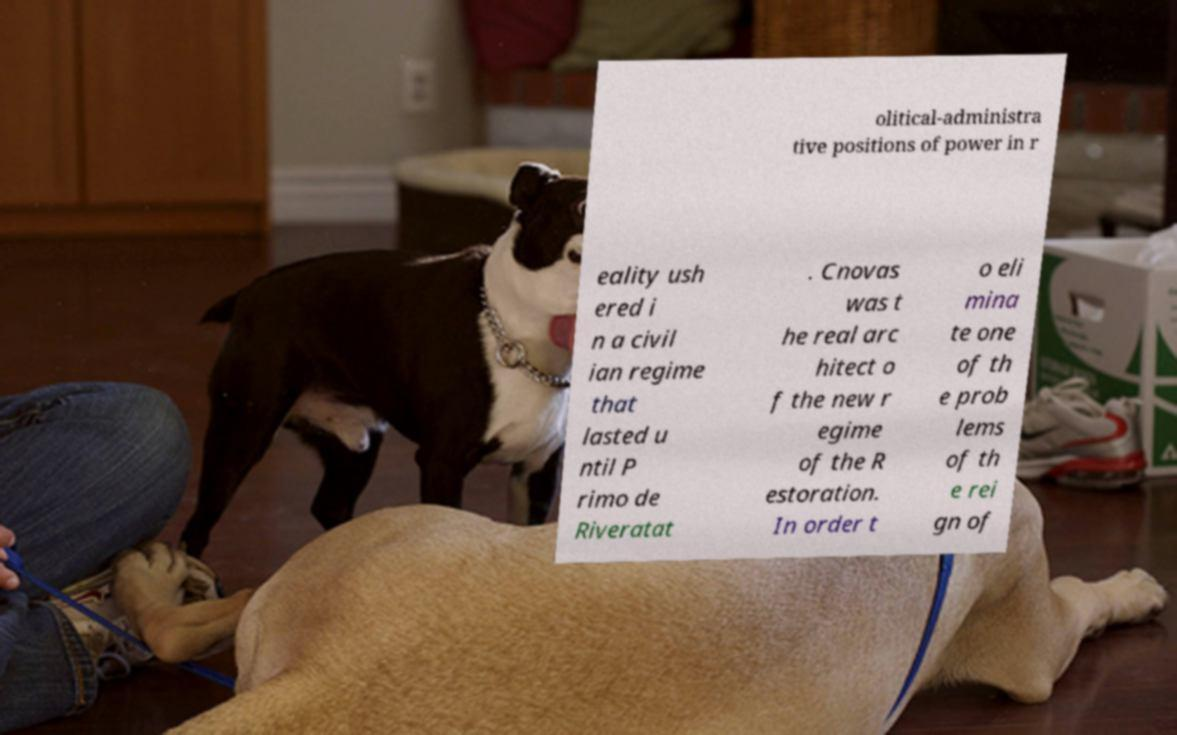Please read and relay the text visible in this image. What does it say? olitical-administra tive positions of power in r eality ush ered i n a civil ian regime that lasted u ntil P rimo de Riveratat . Cnovas was t he real arc hitect o f the new r egime of the R estoration. In order t o eli mina te one of th e prob lems of th e rei gn of 